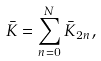<formula> <loc_0><loc_0><loc_500><loc_500>\bar { K } = \sum _ { n = 0 } ^ { N } \bar { K } _ { 2 n } ,</formula> 